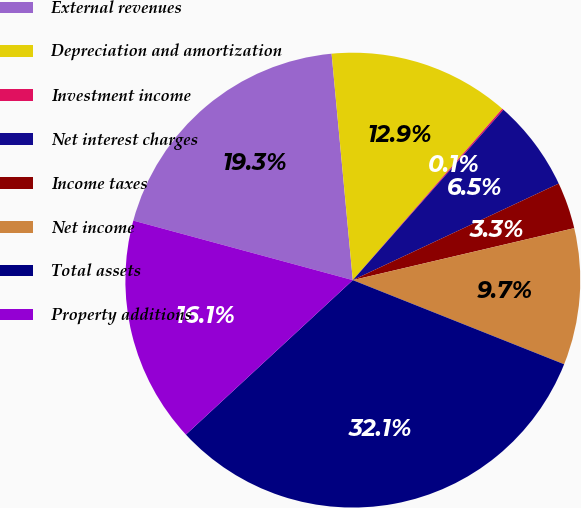Convert chart. <chart><loc_0><loc_0><loc_500><loc_500><pie_chart><fcel>External revenues<fcel>Depreciation and amortization<fcel>Investment income<fcel>Net interest charges<fcel>Income taxes<fcel>Net income<fcel>Total assets<fcel>Property additions<nl><fcel>19.3%<fcel>12.9%<fcel>0.11%<fcel>6.5%<fcel>3.31%<fcel>9.7%<fcel>32.09%<fcel>16.1%<nl></chart> 